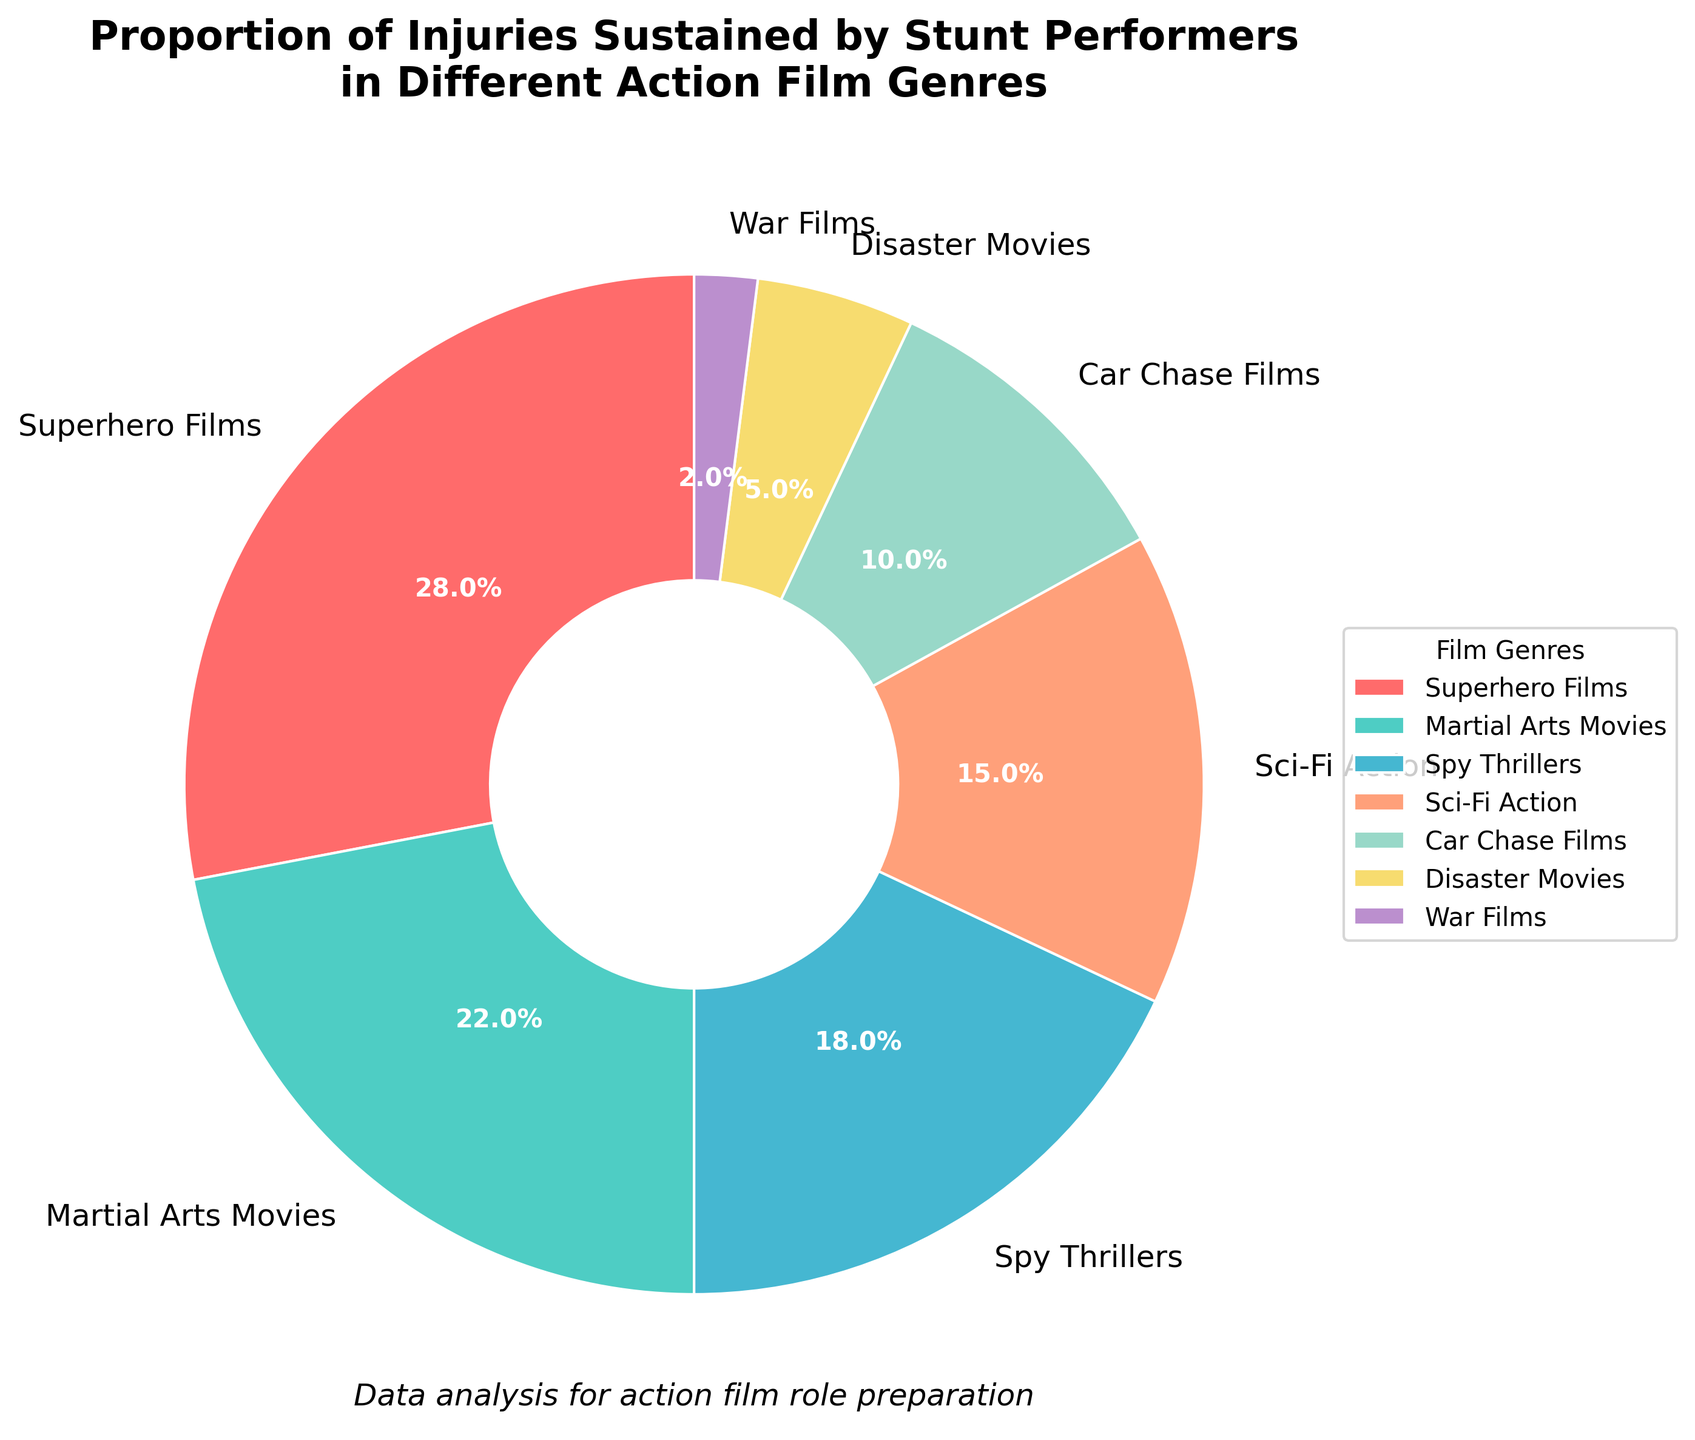What genre has the highest percentage of injuries sustained by stunt performers? Look at the segment with the largest proportion in the pie chart. This will be the genre with the highest percentage.
Answer: Superhero Films Which two genres combined make up the majority of injuries sustained by stunt performers? Add the percentages of the two largest segments until the sum exceeds 50%. Superhero Films (28%) and Martial Arts Movies (22%) together make 28% + 22% = 50%. This represents the majority exactly.
Answer: Superhero Films and Martial Arts Movies Is the percentage of injuries in Sci-Fi Action films greater or less than that in Car Chase films? Compare the percentages of these two segments. Sci-Fi Action films have 15% associated injuries while Car Chase films have 10%.
Answer: Greater What is the combined percentage of injuries for genres that contribute less than 10% each individually? Add the percentages of genres with contributions less than 10%. These are Disaster Movies (5%) and War Films (2%). 5% + 2% = 7%.
Answer: 7% How much greater is the percentage of injuries in Martial Arts Movies compared to Spy Thrillers? Subtract the percentage of injuries in Spy Thrillers from Martial Arts Movies. Martial Arts Movies = 22%, Spy Thrillers = 18%. Therefore, 22% - 18% = 4%.
Answer: 4% Which genre is represented by the yellow segment in the pie chart? Identify the color associated with Disaster Movies in the color legend. Disaster Movies are indicated by the yellow segment.
Answer: Disaster Movies What is the total percentage of injuries from genres that each have 15% injuries or more? Add the percentages of genres with 15% or more: Superhero Films (28%), Martial Arts Movies (22%), Spy Thrillers (18%), Sci-Fi Action (15%). 28% + 22% + 18% + 15% = 83%.
Answer: 83% Does the genre with the smallest percentage of injuries contribute less than 5%? Check the smallest segment in the pie chart. War Films have the smallest percentage with 2%.
Answer: Yes, it contributes less than 5% Which genres have a combined total of 40% of injuries? Find segments that sum up to 40%. Spy Thrillers (18%) + Sci-Fi Action (15%) + Car Chase Films (10%) = 43%, but combining only two would not suffice. Need a different combination. Combining Superhero Films (28%) with another close: Martial Arts Movies (22%) is 50%. So combinations not exactly fitting. Pairing Sci-Fi Action, Car Chase Films and can also try mix with per availability.
Answer: Multiple combinations possible but specifics more easily within larger sub totaling How does the injury percentage of Disaster Movies compare to War Films? Look at the chart and compare the sizes directly. Disaster Movies have 5% and War Films have 2%.
Answer: Greater 